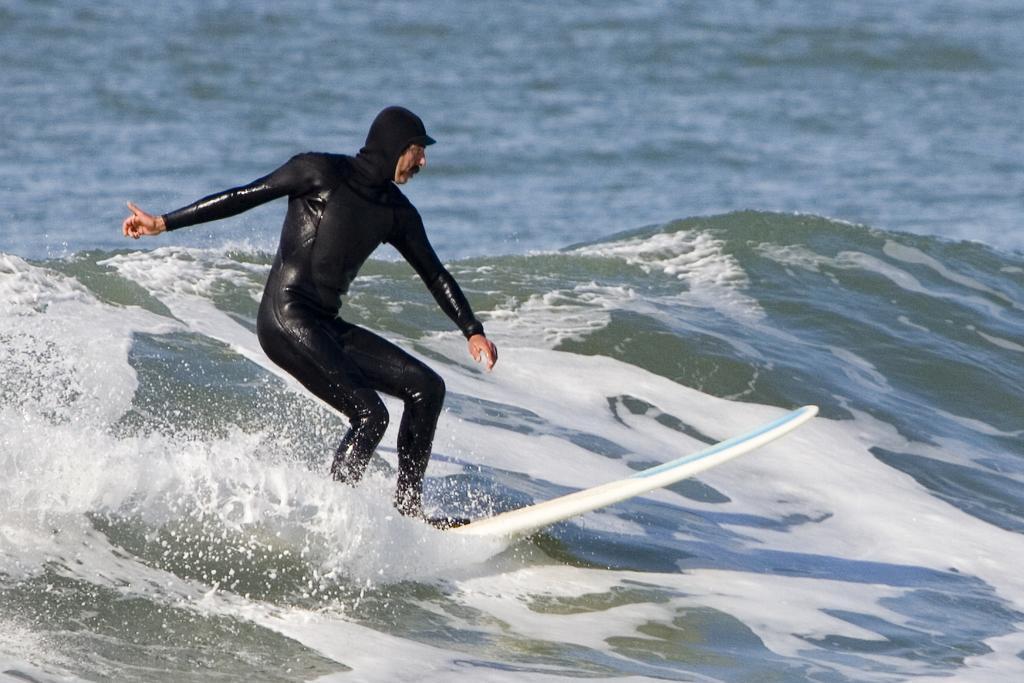Can you describe this image briefly? In this picture I can see there is a man standing on the surface and he is wearing a black swimsuit. There is a heavy tide in the ocean. 